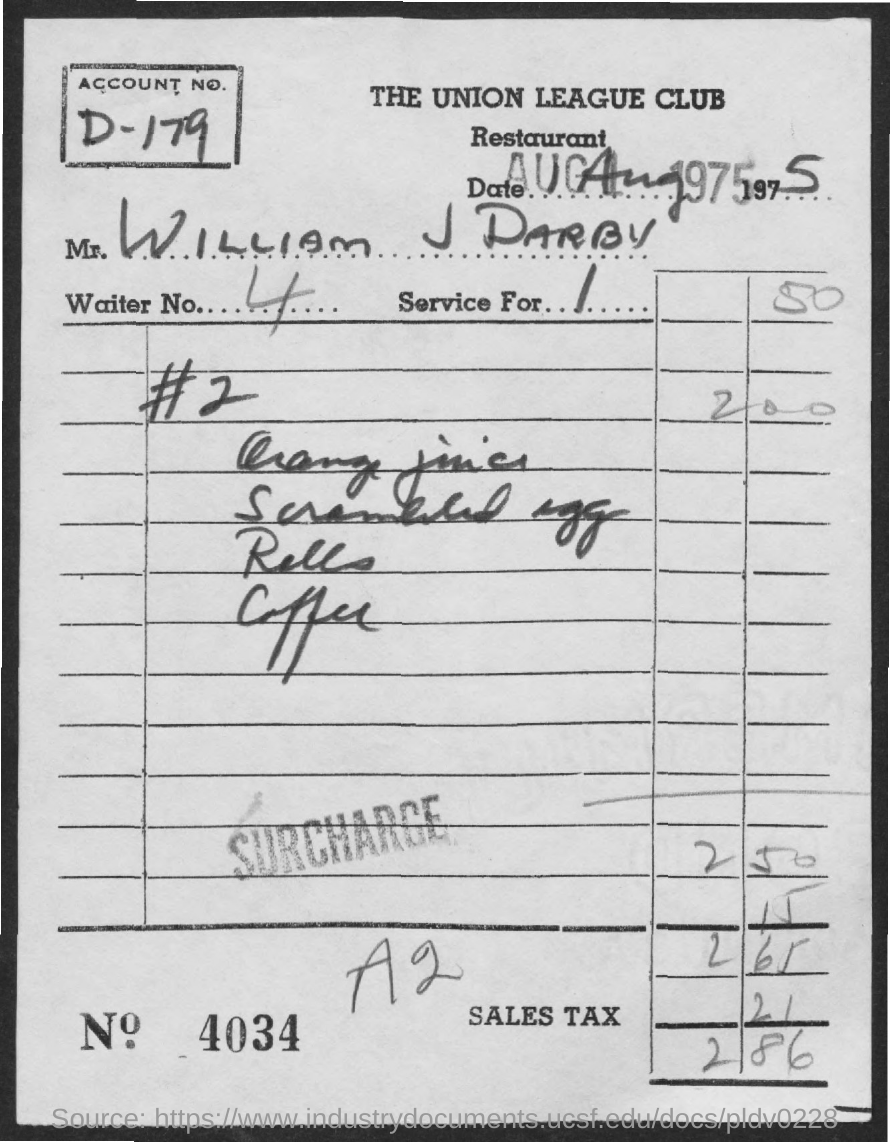Highlight a few significant elements in this photo. The person named in the bill is William J Darby. The waiter provided a bill with a number 4 as the Waiter No. The account number provided on the bill is D-179. 